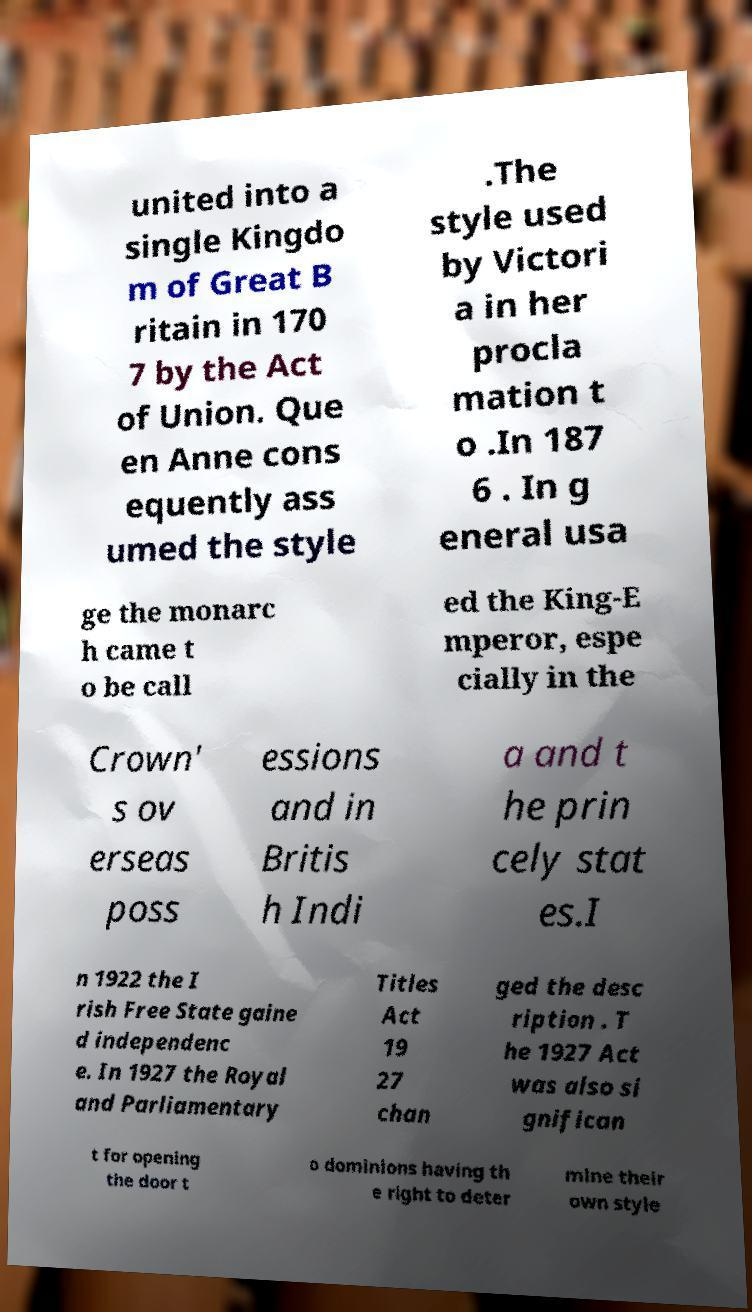Could you extract and type out the text from this image? united into a single Kingdo m of Great B ritain in 170 7 by the Act of Union. Que en Anne cons equently ass umed the style .The style used by Victori a in her procla mation t o .In 187 6 . In g eneral usa ge the monarc h came t o be call ed the King-E mperor, espe cially in the Crown' s ov erseas poss essions and in Britis h Indi a and t he prin cely stat es.I n 1922 the I rish Free State gaine d independenc e. In 1927 the Royal and Parliamentary Titles Act 19 27 chan ged the desc ription . T he 1927 Act was also si gnifican t for opening the door t o dominions having th e right to deter mine their own style 